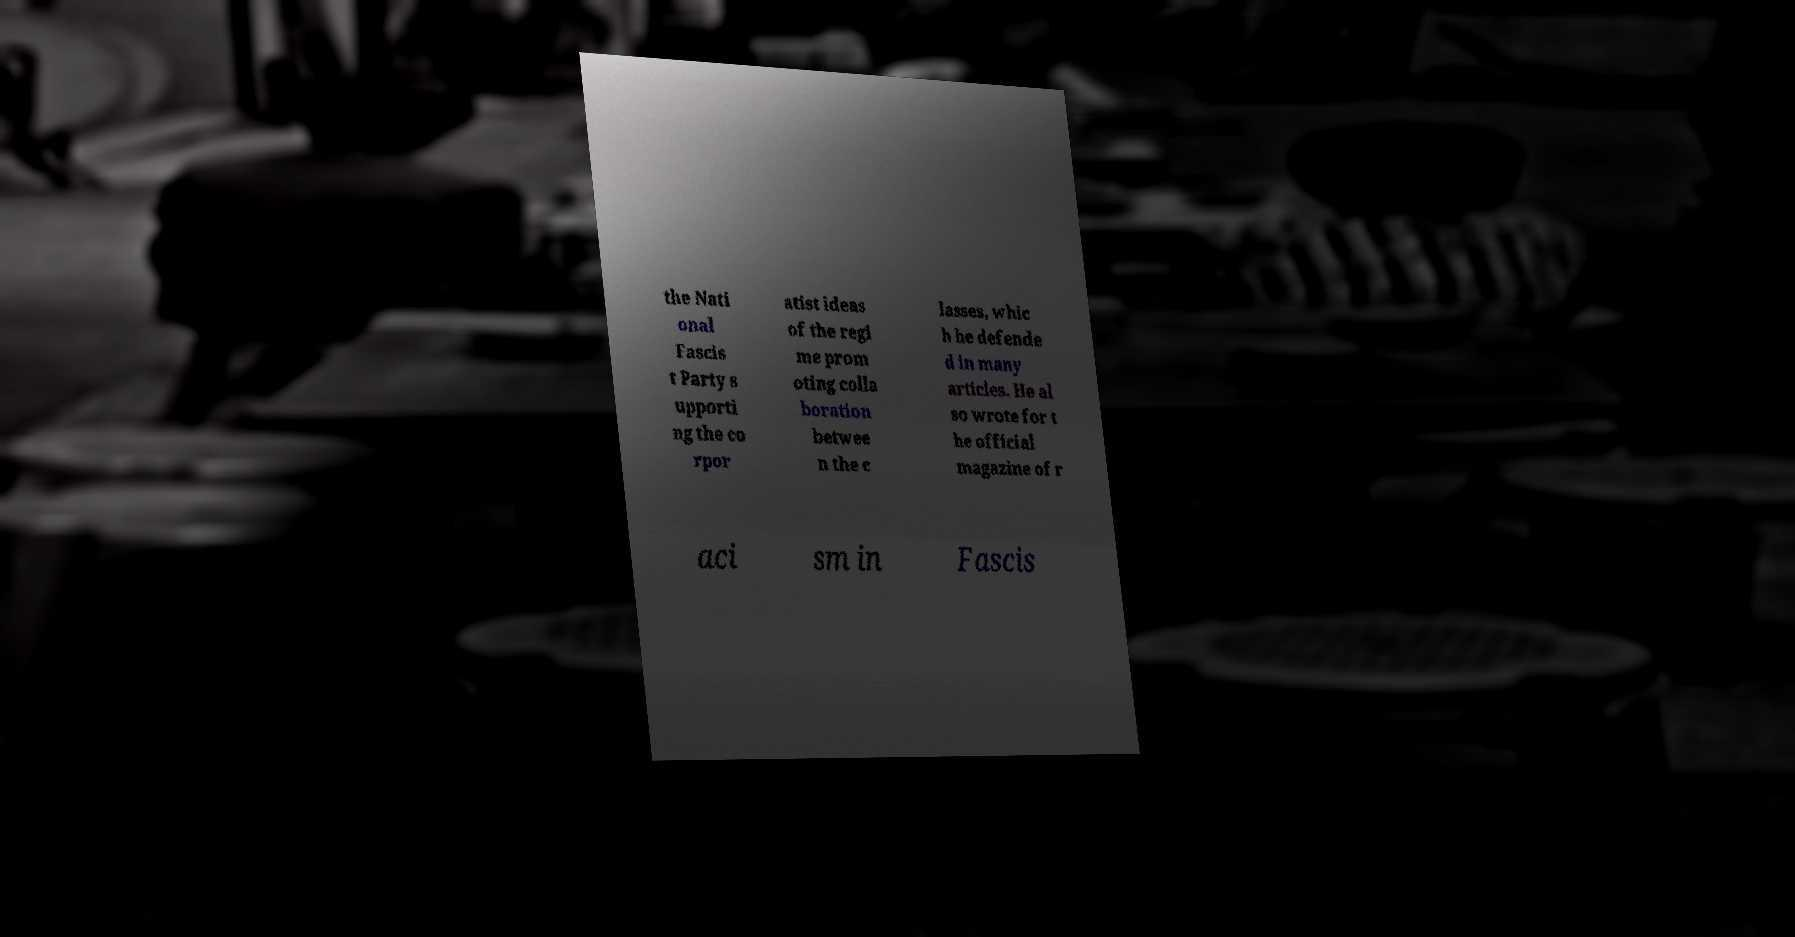There's text embedded in this image that I need extracted. Can you transcribe it verbatim? the Nati onal Fascis t Party s upporti ng the co rpor atist ideas of the regi me prom oting colla boration betwee n the c lasses, whic h he defende d in many articles. He al so wrote for t he official magazine of r aci sm in Fascis 